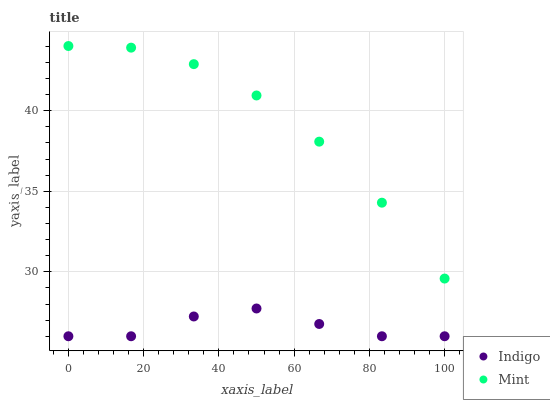Does Indigo have the minimum area under the curve?
Answer yes or no. Yes. Does Mint have the maximum area under the curve?
Answer yes or no. Yes. Does Indigo have the maximum area under the curve?
Answer yes or no. No. Is Indigo the smoothest?
Answer yes or no. Yes. Is Mint the roughest?
Answer yes or no. Yes. Is Indigo the roughest?
Answer yes or no. No. Does Indigo have the lowest value?
Answer yes or no. Yes. Does Mint have the highest value?
Answer yes or no. Yes. Does Indigo have the highest value?
Answer yes or no. No. Is Indigo less than Mint?
Answer yes or no. Yes. Is Mint greater than Indigo?
Answer yes or no. Yes. Does Indigo intersect Mint?
Answer yes or no. No. 